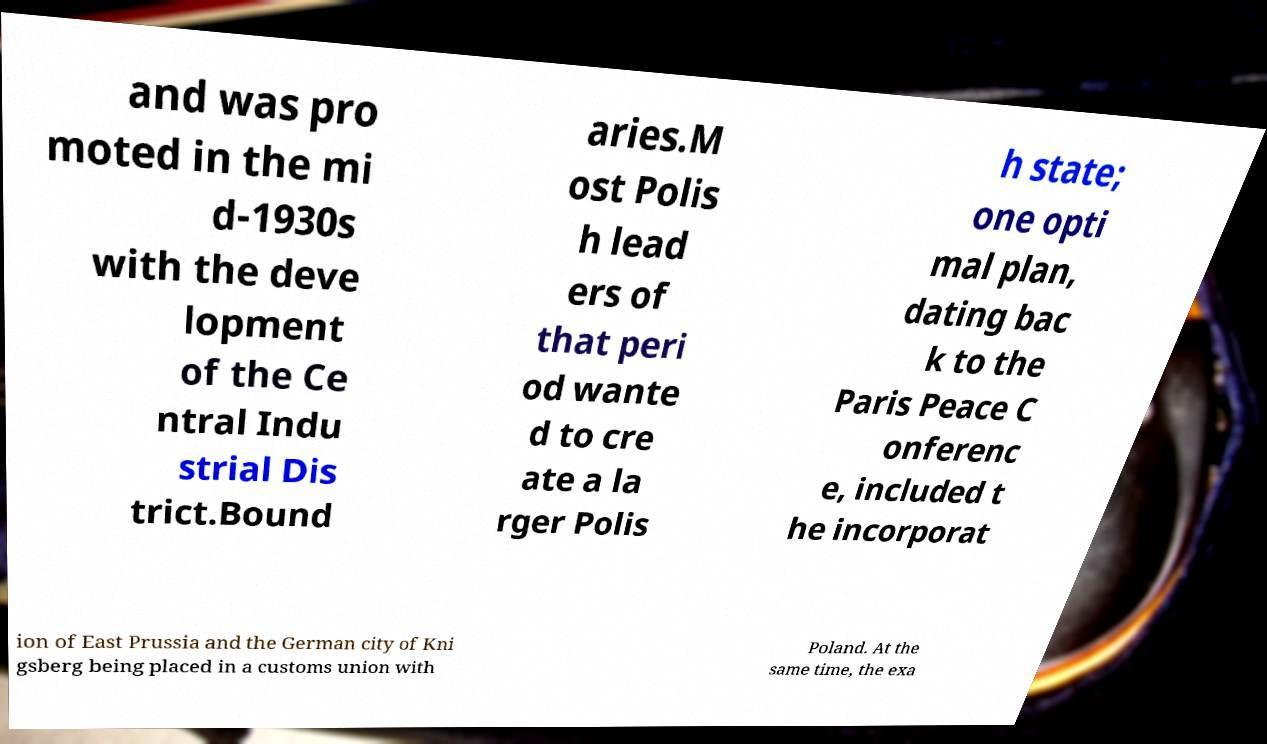Can you read and provide the text displayed in the image?This photo seems to have some interesting text. Can you extract and type it out for me? and was pro moted in the mi d-1930s with the deve lopment of the Ce ntral Indu strial Dis trict.Bound aries.M ost Polis h lead ers of that peri od wante d to cre ate a la rger Polis h state; one opti mal plan, dating bac k to the Paris Peace C onferenc e, included t he incorporat ion of East Prussia and the German city of Kni gsberg being placed in a customs union with Poland. At the same time, the exa 